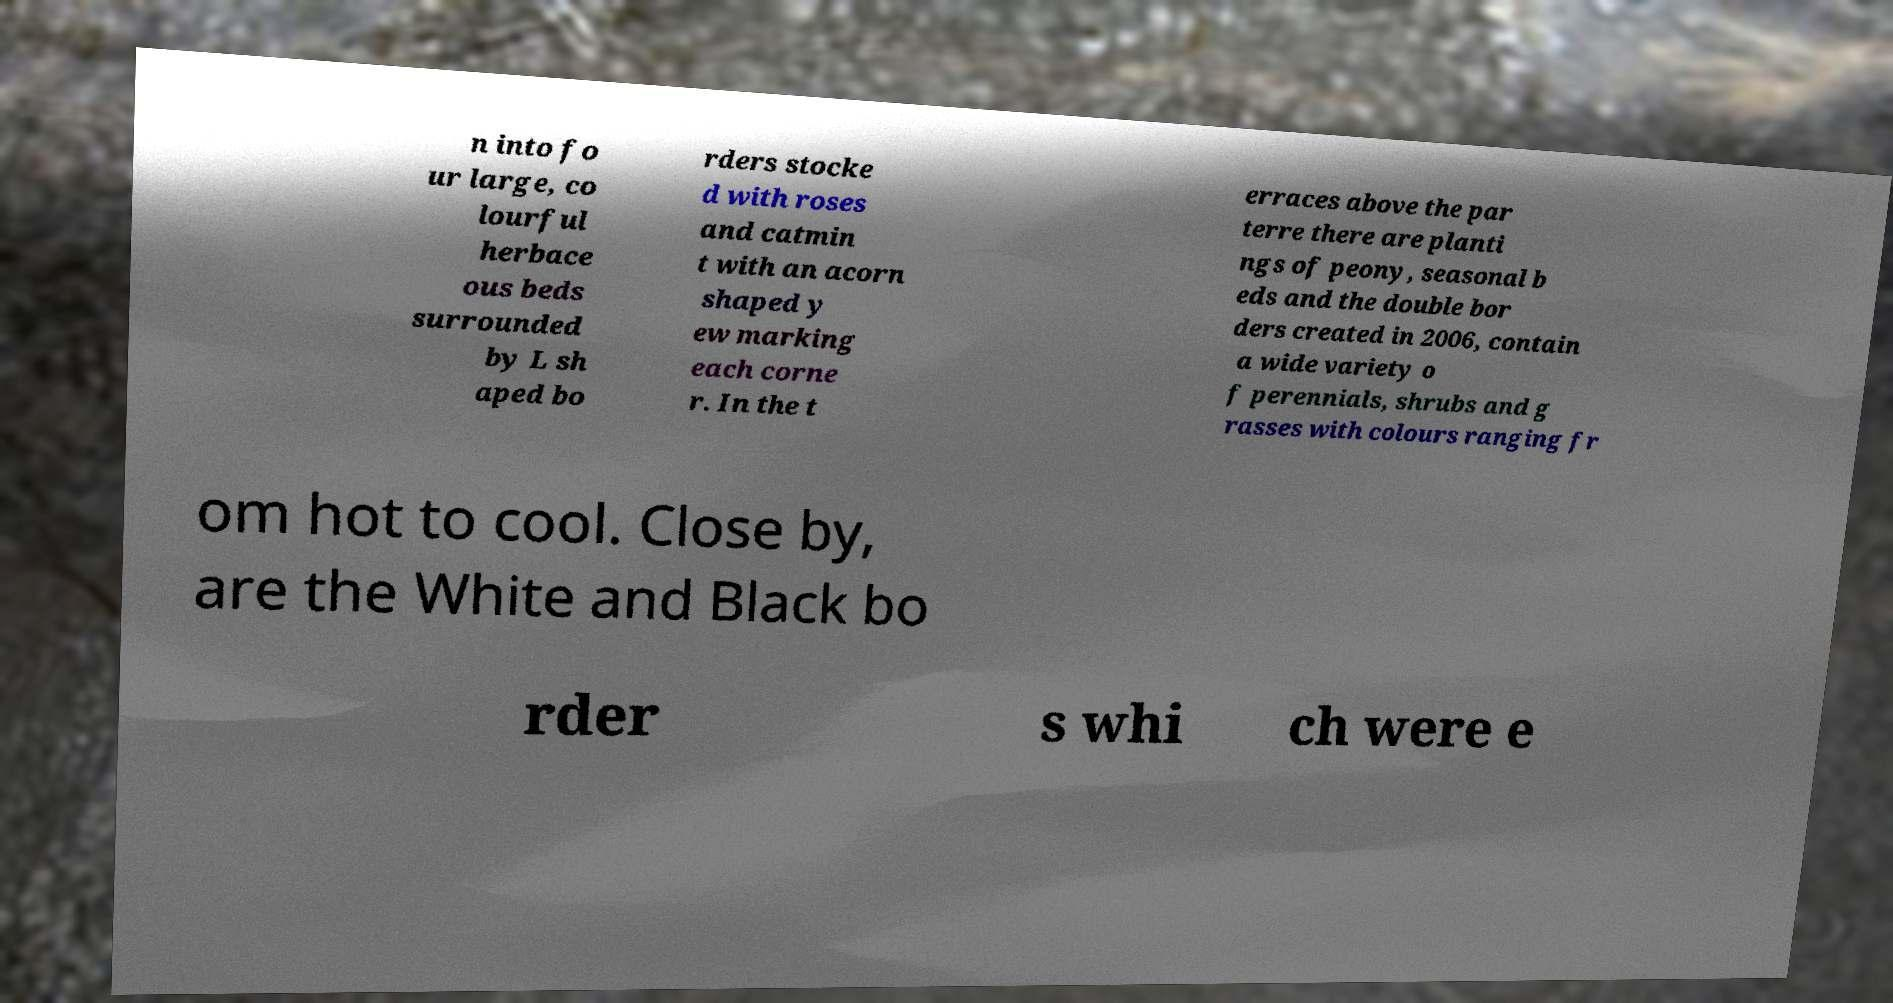Please read and relay the text visible in this image. What does it say? n into fo ur large, co lourful herbace ous beds surrounded by L sh aped bo rders stocke d with roses and catmin t with an acorn shaped y ew marking each corne r. In the t erraces above the par terre there are planti ngs of peony, seasonal b eds and the double bor ders created in 2006, contain a wide variety o f perennials, shrubs and g rasses with colours ranging fr om hot to cool. Close by, are the White and Black bo rder s whi ch were e 